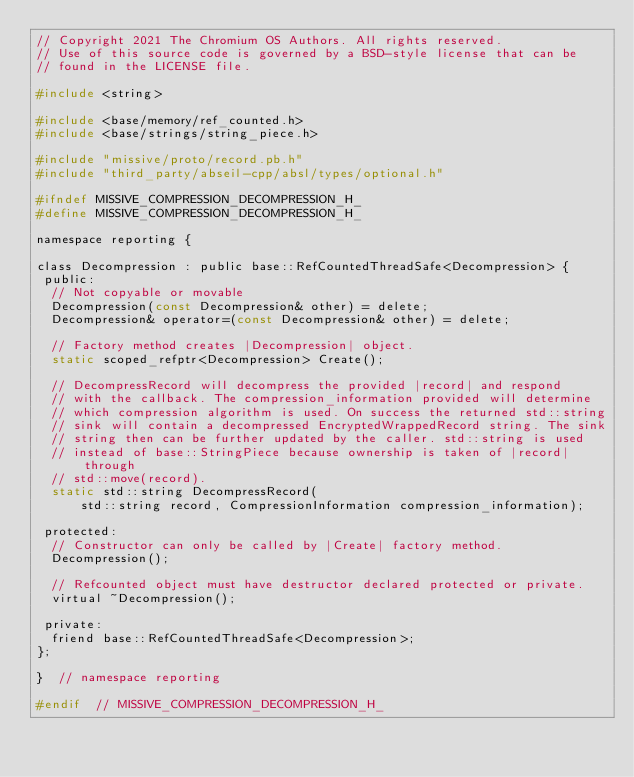Convert code to text. <code><loc_0><loc_0><loc_500><loc_500><_C_>// Copyright 2021 The Chromium OS Authors. All rights reserved.
// Use of this source code is governed by a BSD-style license that can be
// found in the LICENSE file.

#include <string>

#include <base/memory/ref_counted.h>
#include <base/strings/string_piece.h>

#include "missive/proto/record.pb.h"
#include "third_party/abseil-cpp/absl/types/optional.h"

#ifndef MISSIVE_COMPRESSION_DECOMPRESSION_H_
#define MISSIVE_COMPRESSION_DECOMPRESSION_H_

namespace reporting {

class Decompression : public base::RefCountedThreadSafe<Decompression> {
 public:
  // Not copyable or movable
  Decompression(const Decompression& other) = delete;
  Decompression& operator=(const Decompression& other) = delete;

  // Factory method creates |Decompression| object.
  static scoped_refptr<Decompression> Create();

  // DecompressRecord will decompress the provided |record| and respond
  // with the callback. The compression_information provided will determine
  // which compression algorithm is used. On success the returned std::string
  // sink will contain a decompressed EncryptedWrappedRecord string. The sink
  // string then can be further updated by the caller. std::string is used
  // instead of base::StringPiece because ownership is taken of |record| through
  // std::move(record).
  static std::string DecompressRecord(
      std::string record, CompressionInformation compression_information);

 protected:
  // Constructor can only be called by |Create| factory method.
  Decompression();

  // Refcounted object must have destructor declared protected or private.
  virtual ~Decompression();

 private:
  friend base::RefCountedThreadSafe<Decompression>;
};

}  // namespace reporting

#endif  // MISSIVE_COMPRESSION_DECOMPRESSION_H_
</code> 